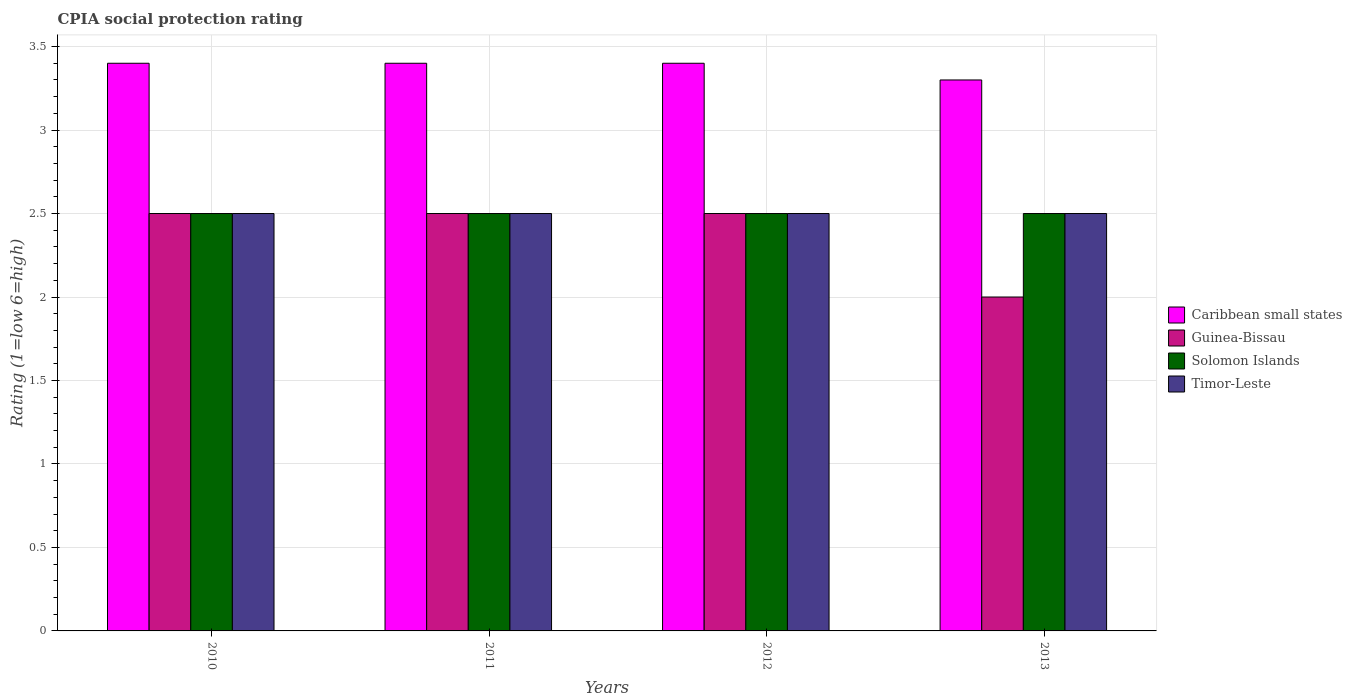How many bars are there on the 3rd tick from the right?
Offer a terse response. 4. In how many cases, is the number of bars for a given year not equal to the number of legend labels?
Give a very brief answer. 0. Across all years, what is the maximum CPIA rating in Guinea-Bissau?
Keep it short and to the point. 2.5. In which year was the CPIA rating in Caribbean small states minimum?
Your response must be concise. 2013. What is the total CPIA rating in Guinea-Bissau in the graph?
Your response must be concise. 9.5. What is the average CPIA rating in Caribbean small states per year?
Your response must be concise. 3.38. Is the CPIA rating in Timor-Leste in 2011 less than that in 2012?
Make the answer very short. No. What is the difference between the highest and the lowest CPIA rating in Caribbean small states?
Your response must be concise. 0.1. In how many years, is the CPIA rating in Timor-Leste greater than the average CPIA rating in Timor-Leste taken over all years?
Your answer should be very brief. 0. Is it the case that in every year, the sum of the CPIA rating in Guinea-Bissau and CPIA rating in Caribbean small states is greater than the sum of CPIA rating in Timor-Leste and CPIA rating in Solomon Islands?
Give a very brief answer. Yes. What does the 2nd bar from the left in 2011 represents?
Your response must be concise. Guinea-Bissau. What does the 1st bar from the right in 2010 represents?
Your answer should be very brief. Timor-Leste. How many bars are there?
Provide a succinct answer. 16. How many years are there in the graph?
Provide a succinct answer. 4. What is the difference between two consecutive major ticks on the Y-axis?
Give a very brief answer. 0.5. Where does the legend appear in the graph?
Offer a terse response. Center right. What is the title of the graph?
Give a very brief answer. CPIA social protection rating. Does "Ireland" appear as one of the legend labels in the graph?
Keep it short and to the point. No. What is the label or title of the X-axis?
Your answer should be compact. Years. What is the label or title of the Y-axis?
Offer a very short reply. Rating (1=low 6=high). What is the Rating (1=low 6=high) of Guinea-Bissau in 2010?
Your answer should be compact. 2.5. What is the Rating (1=low 6=high) in Solomon Islands in 2010?
Ensure brevity in your answer.  2.5. What is the Rating (1=low 6=high) of Caribbean small states in 2011?
Offer a very short reply. 3.4. What is the Rating (1=low 6=high) of Guinea-Bissau in 2011?
Give a very brief answer. 2.5. What is the Rating (1=low 6=high) in Solomon Islands in 2012?
Keep it short and to the point. 2.5. What is the Rating (1=low 6=high) of Solomon Islands in 2013?
Your answer should be compact. 2.5. What is the Rating (1=low 6=high) of Timor-Leste in 2013?
Your answer should be very brief. 2.5. Across all years, what is the maximum Rating (1=low 6=high) in Caribbean small states?
Offer a terse response. 3.4. Across all years, what is the maximum Rating (1=low 6=high) of Solomon Islands?
Your answer should be very brief. 2.5. Across all years, what is the maximum Rating (1=low 6=high) of Timor-Leste?
Your answer should be very brief. 2.5. Across all years, what is the minimum Rating (1=low 6=high) in Guinea-Bissau?
Give a very brief answer. 2. What is the difference between the Rating (1=low 6=high) of Timor-Leste in 2010 and that in 2011?
Give a very brief answer. 0. What is the difference between the Rating (1=low 6=high) in Guinea-Bissau in 2010 and that in 2012?
Give a very brief answer. 0. What is the difference between the Rating (1=low 6=high) of Timor-Leste in 2010 and that in 2012?
Give a very brief answer. 0. What is the difference between the Rating (1=low 6=high) of Guinea-Bissau in 2010 and that in 2013?
Provide a short and direct response. 0.5. What is the difference between the Rating (1=low 6=high) in Solomon Islands in 2010 and that in 2013?
Offer a terse response. 0. What is the difference between the Rating (1=low 6=high) in Caribbean small states in 2011 and that in 2012?
Your answer should be compact. 0. What is the difference between the Rating (1=low 6=high) of Guinea-Bissau in 2011 and that in 2012?
Offer a very short reply. 0. What is the difference between the Rating (1=low 6=high) in Caribbean small states in 2011 and that in 2013?
Keep it short and to the point. 0.1. What is the difference between the Rating (1=low 6=high) in Timor-Leste in 2011 and that in 2013?
Keep it short and to the point. 0. What is the difference between the Rating (1=low 6=high) in Guinea-Bissau in 2012 and that in 2013?
Provide a succinct answer. 0.5. What is the difference between the Rating (1=low 6=high) of Timor-Leste in 2012 and that in 2013?
Your response must be concise. 0. What is the difference between the Rating (1=low 6=high) of Guinea-Bissau in 2010 and the Rating (1=low 6=high) of Solomon Islands in 2011?
Offer a terse response. 0. What is the difference between the Rating (1=low 6=high) in Caribbean small states in 2010 and the Rating (1=low 6=high) in Timor-Leste in 2012?
Your answer should be compact. 0.9. What is the difference between the Rating (1=low 6=high) of Solomon Islands in 2010 and the Rating (1=low 6=high) of Timor-Leste in 2012?
Ensure brevity in your answer.  0. What is the difference between the Rating (1=low 6=high) in Caribbean small states in 2010 and the Rating (1=low 6=high) in Solomon Islands in 2013?
Provide a succinct answer. 0.9. What is the difference between the Rating (1=low 6=high) of Solomon Islands in 2010 and the Rating (1=low 6=high) of Timor-Leste in 2013?
Your answer should be compact. 0. What is the difference between the Rating (1=low 6=high) in Caribbean small states in 2011 and the Rating (1=low 6=high) in Guinea-Bissau in 2012?
Give a very brief answer. 0.9. What is the difference between the Rating (1=low 6=high) of Caribbean small states in 2011 and the Rating (1=low 6=high) of Timor-Leste in 2012?
Your response must be concise. 0.9. What is the difference between the Rating (1=low 6=high) in Guinea-Bissau in 2011 and the Rating (1=low 6=high) in Timor-Leste in 2012?
Your answer should be very brief. 0. What is the difference between the Rating (1=low 6=high) of Solomon Islands in 2011 and the Rating (1=low 6=high) of Timor-Leste in 2012?
Your answer should be compact. 0. What is the difference between the Rating (1=low 6=high) in Caribbean small states in 2011 and the Rating (1=low 6=high) in Guinea-Bissau in 2013?
Offer a terse response. 1.4. What is the difference between the Rating (1=low 6=high) of Caribbean small states in 2011 and the Rating (1=low 6=high) of Solomon Islands in 2013?
Your response must be concise. 0.9. What is the difference between the Rating (1=low 6=high) of Caribbean small states in 2011 and the Rating (1=low 6=high) of Timor-Leste in 2013?
Keep it short and to the point. 0.9. What is the difference between the Rating (1=low 6=high) in Guinea-Bissau in 2011 and the Rating (1=low 6=high) in Timor-Leste in 2013?
Make the answer very short. 0. What is the difference between the Rating (1=low 6=high) in Caribbean small states in 2012 and the Rating (1=low 6=high) in Guinea-Bissau in 2013?
Your answer should be very brief. 1.4. What is the difference between the Rating (1=low 6=high) of Guinea-Bissau in 2012 and the Rating (1=low 6=high) of Solomon Islands in 2013?
Make the answer very short. 0. What is the difference between the Rating (1=low 6=high) of Guinea-Bissau in 2012 and the Rating (1=low 6=high) of Timor-Leste in 2013?
Offer a terse response. 0. What is the difference between the Rating (1=low 6=high) in Solomon Islands in 2012 and the Rating (1=low 6=high) in Timor-Leste in 2013?
Offer a very short reply. 0. What is the average Rating (1=low 6=high) of Caribbean small states per year?
Your answer should be compact. 3.38. What is the average Rating (1=low 6=high) of Guinea-Bissau per year?
Make the answer very short. 2.38. In the year 2010, what is the difference between the Rating (1=low 6=high) in Caribbean small states and Rating (1=low 6=high) in Guinea-Bissau?
Ensure brevity in your answer.  0.9. In the year 2010, what is the difference between the Rating (1=low 6=high) in Caribbean small states and Rating (1=low 6=high) in Timor-Leste?
Offer a terse response. 0.9. In the year 2010, what is the difference between the Rating (1=low 6=high) of Guinea-Bissau and Rating (1=low 6=high) of Solomon Islands?
Provide a short and direct response. 0. In the year 2010, what is the difference between the Rating (1=low 6=high) in Guinea-Bissau and Rating (1=low 6=high) in Timor-Leste?
Make the answer very short. 0. In the year 2010, what is the difference between the Rating (1=low 6=high) in Solomon Islands and Rating (1=low 6=high) in Timor-Leste?
Your answer should be compact. 0. In the year 2011, what is the difference between the Rating (1=low 6=high) of Caribbean small states and Rating (1=low 6=high) of Guinea-Bissau?
Make the answer very short. 0.9. In the year 2011, what is the difference between the Rating (1=low 6=high) in Caribbean small states and Rating (1=low 6=high) in Timor-Leste?
Provide a succinct answer. 0.9. In the year 2013, what is the difference between the Rating (1=low 6=high) of Caribbean small states and Rating (1=low 6=high) of Guinea-Bissau?
Your answer should be compact. 1.3. In the year 2013, what is the difference between the Rating (1=low 6=high) in Caribbean small states and Rating (1=low 6=high) in Solomon Islands?
Your response must be concise. 0.8. In the year 2013, what is the difference between the Rating (1=low 6=high) in Caribbean small states and Rating (1=low 6=high) in Timor-Leste?
Offer a terse response. 0.8. In the year 2013, what is the difference between the Rating (1=low 6=high) in Guinea-Bissau and Rating (1=low 6=high) in Timor-Leste?
Ensure brevity in your answer.  -0.5. In the year 2013, what is the difference between the Rating (1=low 6=high) of Solomon Islands and Rating (1=low 6=high) of Timor-Leste?
Offer a terse response. 0. What is the ratio of the Rating (1=low 6=high) of Caribbean small states in 2010 to that in 2011?
Provide a short and direct response. 1. What is the ratio of the Rating (1=low 6=high) of Guinea-Bissau in 2010 to that in 2012?
Provide a short and direct response. 1. What is the ratio of the Rating (1=low 6=high) in Solomon Islands in 2010 to that in 2012?
Your answer should be very brief. 1. What is the ratio of the Rating (1=low 6=high) of Timor-Leste in 2010 to that in 2012?
Offer a very short reply. 1. What is the ratio of the Rating (1=low 6=high) in Caribbean small states in 2010 to that in 2013?
Your answer should be very brief. 1.03. What is the ratio of the Rating (1=low 6=high) of Guinea-Bissau in 2010 to that in 2013?
Ensure brevity in your answer.  1.25. What is the ratio of the Rating (1=low 6=high) in Solomon Islands in 2010 to that in 2013?
Provide a short and direct response. 1. What is the ratio of the Rating (1=low 6=high) of Timor-Leste in 2010 to that in 2013?
Keep it short and to the point. 1. What is the ratio of the Rating (1=low 6=high) of Guinea-Bissau in 2011 to that in 2012?
Your response must be concise. 1. What is the ratio of the Rating (1=low 6=high) of Solomon Islands in 2011 to that in 2012?
Provide a succinct answer. 1. What is the ratio of the Rating (1=low 6=high) of Caribbean small states in 2011 to that in 2013?
Your answer should be very brief. 1.03. What is the ratio of the Rating (1=low 6=high) of Solomon Islands in 2011 to that in 2013?
Give a very brief answer. 1. What is the ratio of the Rating (1=low 6=high) in Timor-Leste in 2011 to that in 2013?
Ensure brevity in your answer.  1. What is the ratio of the Rating (1=low 6=high) of Caribbean small states in 2012 to that in 2013?
Offer a terse response. 1.03. What is the ratio of the Rating (1=low 6=high) of Guinea-Bissau in 2012 to that in 2013?
Offer a very short reply. 1.25. What is the difference between the highest and the second highest Rating (1=low 6=high) of Caribbean small states?
Your answer should be compact. 0. What is the difference between the highest and the second highest Rating (1=low 6=high) of Solomon Islands?
Make the answer very short. 0. What is the difference between the highest and the lowest Rating (1=low 6=high) of Caribbean small states?
Provide a succinct answer. 0.1. What is the difference between the highest and the lowest Rating (1=low 6=high) of Timor-Leste?
Provide a succinct answer. 0. 